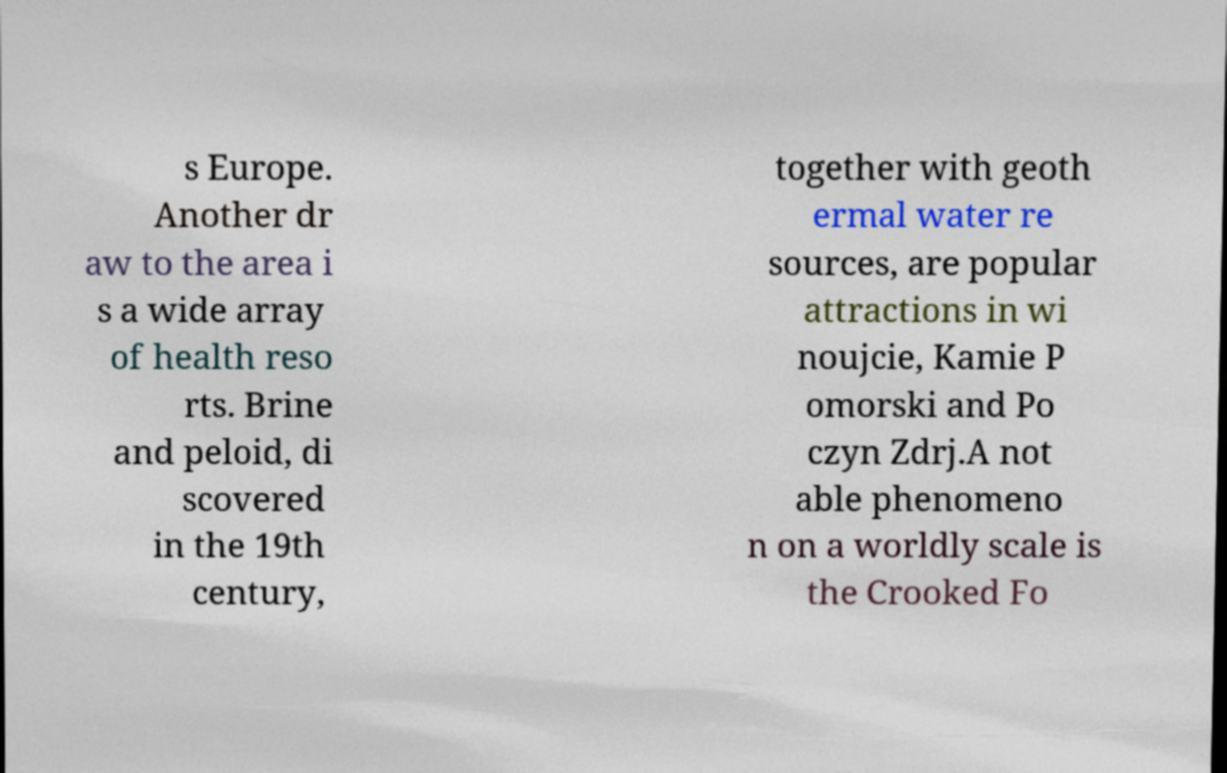For documentation purposes, I need the text within this image transcribed. Could you provide that? s Europe. Another dr aw to the area i s a wide array of health reso rts. Brine and peloid, di scovered in the 19th century, together with geoth ermal water re sources, are popular attractions in wi noujcie, Kamie P omorski and Po czyn Zdrj.A not able phenomeno n on a worldly scale is the Crooked Fo 